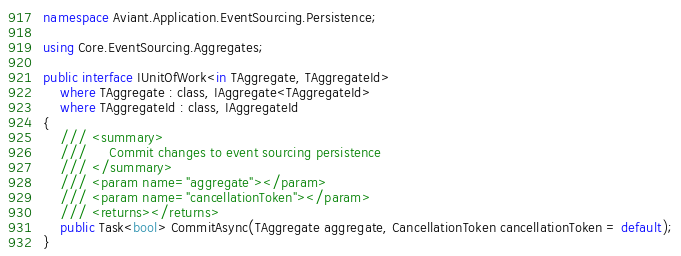<code> <loc_0><loc_0><loc_500><loc_500><_C#_>namespace Aviant.Application.EventSourcing.Persistence;

using Core.EventSourcing.Aggregates;

public interface IUnitOfWork<in TAggregate, TAggregateId>
    where TAggregate : class, IAggregate<TAggregateId>
    where TAggregateId : class, IAggregateId
{
    /// <summary>
    ///     Commit changes to event sourcing persistence
    /// </summary>
    /// <param name="aggregate"></param>
    /// <param name="cancellationToken"></param>
    /// <returns></returns>
    public Task<bool> CommitAsync(TAggregate aggregate, CancellationToken cancellationToken = default);
}
</code> 